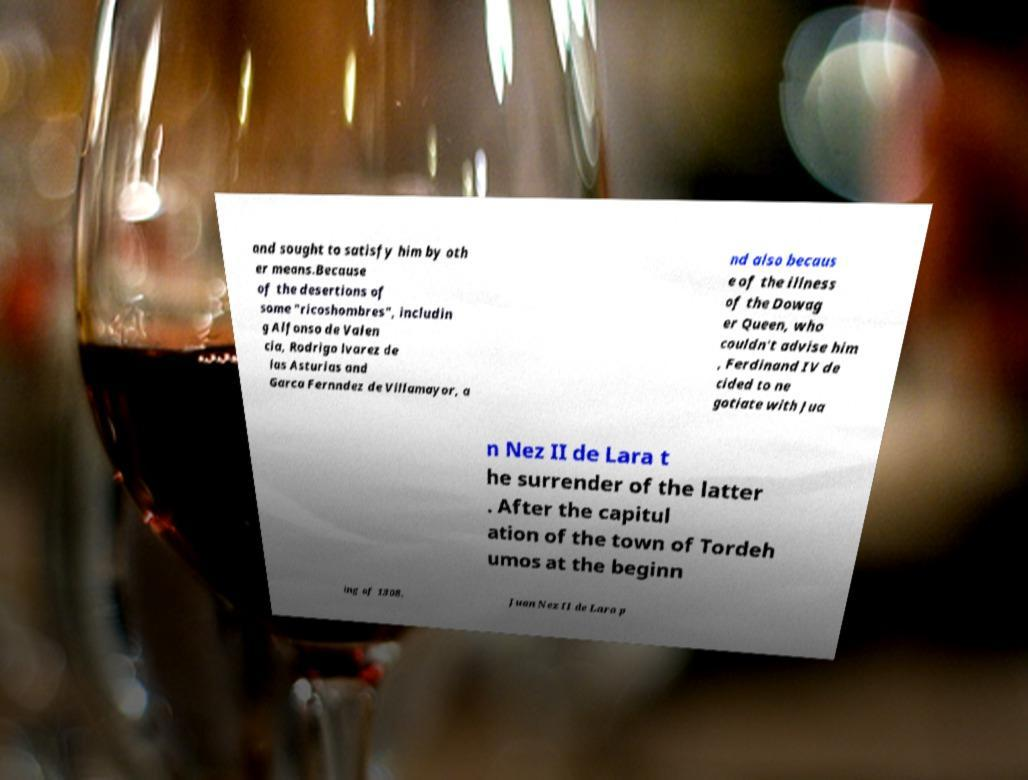For documentation purposes, I need the text within this image transcribed. Could you provide that? and sought to satisfy him by oth er means.Because of the desertions of some "ricoshombres", includin g Alfonso de Valen cia, Rodrigo lvarez de las Asturias and Garca Fernndez de Villamayor, a nd also becaus e of the illness of the Dowag er Queen, who couldn't advise him , Ferdinand IV de cided to ne gotiate with Jua n Nez II de Lara t he surrender of the latter . After the capitul ation of the town of Tordeh umos at the beginn ing of 1308, Juan Nez II de Lara p 